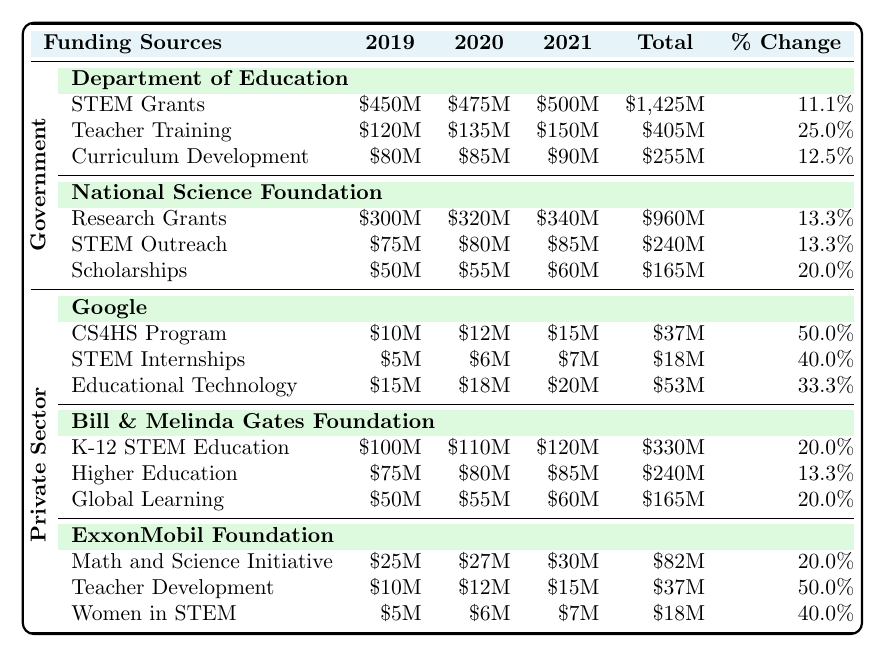What were the total government allocations for STEM education in 2020? To find the total government allocations for STEM education in 2020, we add the Department of Education (STEM Grants + Teacher Training + Curriculum Development) and the National Science Foundation (Research Grants + STEM Outreach + Scholarships). The sums are: Department of Education: 475M + 135M + 85M = 695M; National Science Foundation: 320M + 80M + 55M = 455M. Thus, 695M + 455M = 1150M.
Answer: 1150M Which private sector initiative had the highest funding in 2021? To determine which private sector initiative had the highest funding in 2021, we compare the amounts: Google (CS4HS Program 15M + STEM Internships 7M + Educational Technology 20M = 42M), Bill & Melinda Gates Foundation (K-12 STEM Education 120M + Higher Education 85M + Global Learning 60M = 265M), and ExxonMobil Foundation (Math and Science Initiative 30M + Teacher Development 15M + Women in STEM 7M = 52M). Bill & Melinda Gates Foundation with 265M is the highest.
Answer: Bill & Melinda Gates Foundation What was the percentage change in funding for Teacher Training from 2019 to 2021? The percentage change formula is (New Value - Old Value) / Old Value * 100. Teacher Training in 2019 was 120M and in 2021 was 150M. The change is (150M - 120M) / 120M * 100 = 25%.
Answer: 25% Did the funding for Women in STEM increase every year from 2019 to 2021? To assess if funding for Women in STEM increased every year, we examine the yearly values: 2019 was 5M, 2020 was 6M, and 2021 was 7M. All years show an increase.
Answer: Yes What is the total funding allocation for Curriculum Development across all years? The total for Curriculum Development is found by adding up the yearly values: 80M in 2019, 85M in 2020, and 90M in 2021, which equals 80M + 85M + 90M = 255M.
Answer: 255M Which department saw the largest percentage increase in funding between 2019 and 2021? Calculate the percentage increase for each department: Department of Education’s STEM Grants increased from 450M to 500M, a 11.1% increase; Teacher Training increased from 120M to 150M, a 25% increase; Curriculum Development from 80M to 90M, a 12.5% increase; National Science Foundation had percentages of 13.3%, 20%, and 13.3% for its initiatives. Teacher Training had the largest increase of 25%.
Answer: Teacher Training How much more did the National Science Foundation allocate for Research Grants in 2021 compared to 2019? To get the difference, subtract the 2019 funding (300M) from the 2021 funding (340M). The calculation is 340M - 300M = 40M more allocated in 2021.
Answer: 40M Was the total funding for all private sector initiatives higher than that of government initiatives in 2020? Calculate total funding for private sector in 2020 (Google 12M + 6M + 18M = 36M; Gates Foundation 110M + 80M + 55M = 245M; ExxonMobil Foundation 27M + 12M + 6M = 45M, totaling 36M + 245M + 45M = 326M) and government (2020: Department of Education 695M; National Science Foundation 455M, totaling 1150M). Since 326M is less than 1150M, the answer is no.
Answer: No What was the average annual funding for the Bill & Melinda Gates Foundation from 2019 to 2021? To find the average, sum the yearly funds: K-12 STEM Education (100M + 110M + 120M) + Higher Education (75M + 80M + 85M) + Global Learning (50M + 55M + 60M) totals to 330M + 240M + 165M = 735M. Then divide by 3 years: 735M / 3 = 245M average per year.
Answer: 245M In how many areas did Google increase funding from 2019 to 2021? Review funding from Google in 2019, 2020, and 2021: CS4HS increased from 10M to 15M, STEM Internships from 5M to 7M, and Educational Technology from 15M to 20M. All areas saw increases. Thus, Google increased funding in three areas.
Answer: Three areas 